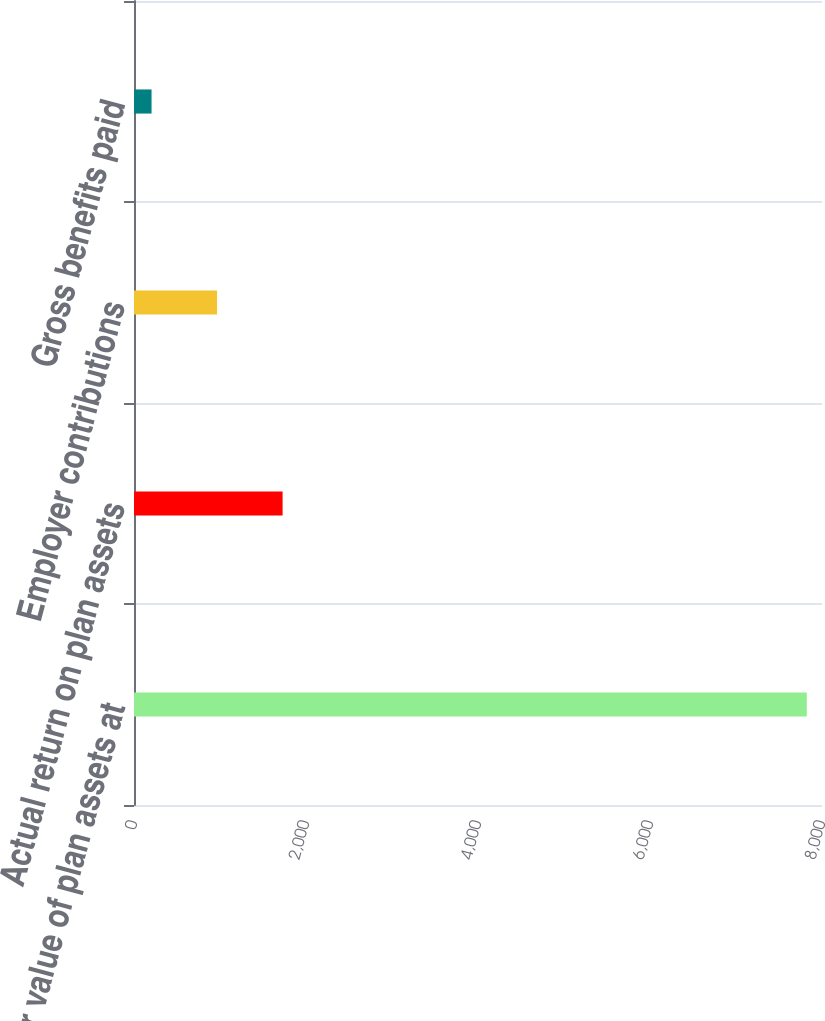<chart> <loc_0><loc_0><loc_500><loc_500><bar_chart><fcel>Fair value of plan assets at<fcel>Actual return on plan assets<fcel>Employer contributions<fcel>Gross benefits paid<nl><fcel>7823<fcel>1727.8<fcel>965.9<fcel>204<nl></chart> 